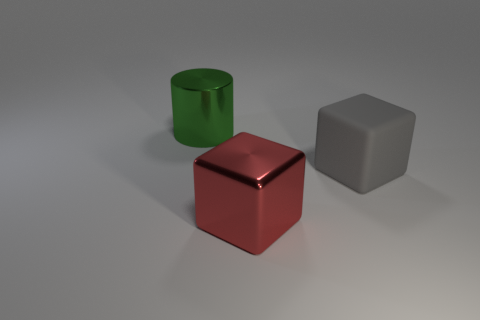Are there any gray rubber things?
Your answer should be very brief. Yes. Is the number of large gray matte blocks that are in front of the shiny cylinder greater than the number of blocks in front of the big matte object?
Your answer should be very brief. No. There is a large metal object that is to the left of the large metallic object that is right of the cylinder; what is its color?
Provide a succinct answer. Green. Are there any tiny rubber objects that have the same color as the cylinder?
Give a very brief answer. No. How big is the metal object that is in front of the thing that is on the left side of the metal thing that is in front of the big rubber thing?
Offer a very short reply. Large. What is the shape of the big green thing?
Give a very brief answer. Cylinder. What number of gray matte objects are behind the metallic thing right of the shiny cylinder?
Ensure brevity in your answer.  1. What number of other objects are the same material as the green cylinder?
Provide a short and direct response. 1. Is the block in front of the gray object made of the same material as the cylinder that is left of the matte thing?
Provide a succinct answer. Yes. Are there any other things that are the same shape as the large matte object?
Offer a terse response. Yes. 